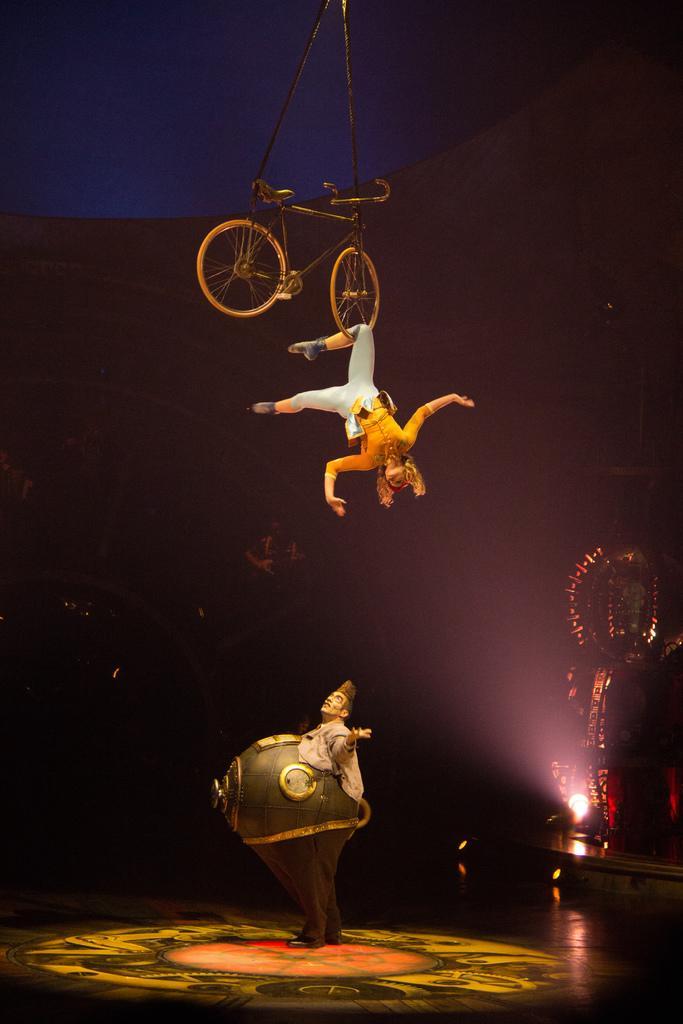Can you describe this image briefly? In this image I can see the two people wearing the costumes. I can see one person and the bicycle in the air. To the right I can see the light and an object. And there is a black and blue background. 